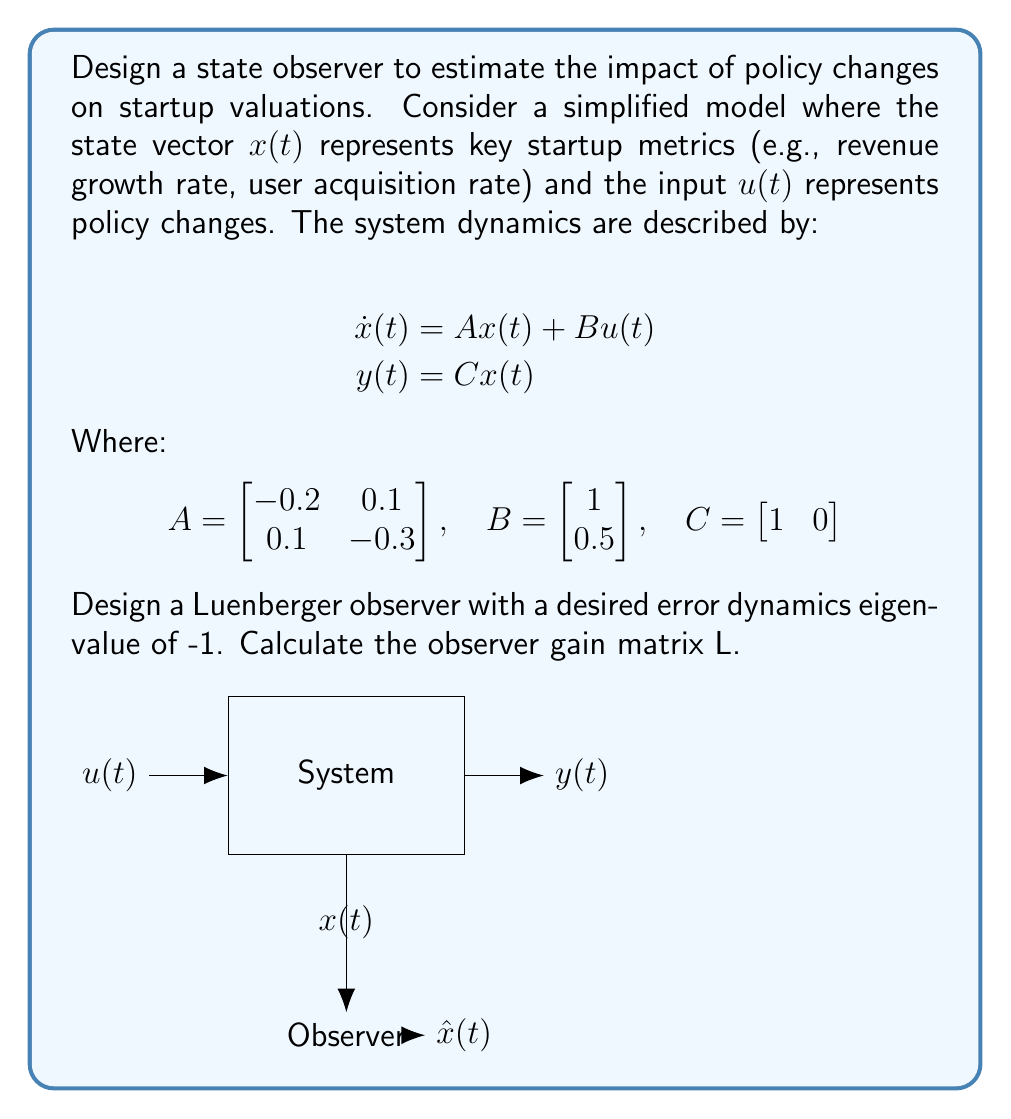What is the answer to this math problem? To design a Luenberger observer, we need to follow these steps:

1) First, we need to check if the system is observable. The observability matrix is:

   $$O = \begin{bmatrix} C \\ CA \end{bmatrix} = \begin{bmatrix} 1 & 0 \\ -0.2 & 0.1 \end{bmatrix}$$

   The rank of O is 2, which is equal to the dimension of the state space, so the system is observable.

2) The observer dynamics are given by:

   $$\dot{\hat{x}}(t) = A\hat{x}(t) + Bu(t) + L(y(t) - C\hat{x}(t))$$

   Where L is the observer gain matrix we need to calculate.

3) The error dynamics are given by:

   $$\dot{e}(t) = (A - LC)e(t)$$

4) We want the eigenvalues of (A - LC) to be -1. So we need to solve:

   $$det(sI - (A - LC)) = (s + 1)^2$$

5) Expanding this:

   $$\begin{vmatrix} s+0.2+l_1 & -0.1 \\ -0.1 & s+0.3 \end{vmatrix} = s^2 + 2s + 1$$

   Where $L = \begin{bmatrix} l_1 \\ l_2 \end{bmatrix}$

6) Equating coefficients:

   $s^2: 1 = 1$
   $s^1: 0.5 + l_1 = 2$
   $s^0: 0.06 + 0.3l_1 + 0.1l_2 = 1$

7) From the second equation:
   $l_1 = 1.5$

8) Substituting this into the third equation:
   $0.06 + 0.3(1.5) + 0.1l_2 = 1$
   $0.51 + 0.1l_2 = 1$
   $0.1l_2 = 0.49$
   $l_2 = 4.9$

Therefore, the observer gain matrix L is:

$$L = \begin{bmatrix} 1.5 \\ 4.9 \end{bmatrix}$$
Answer: $$L = \begin{bmatrix} 1.5 \\ 4.9 \end{bmatrix}$$ 